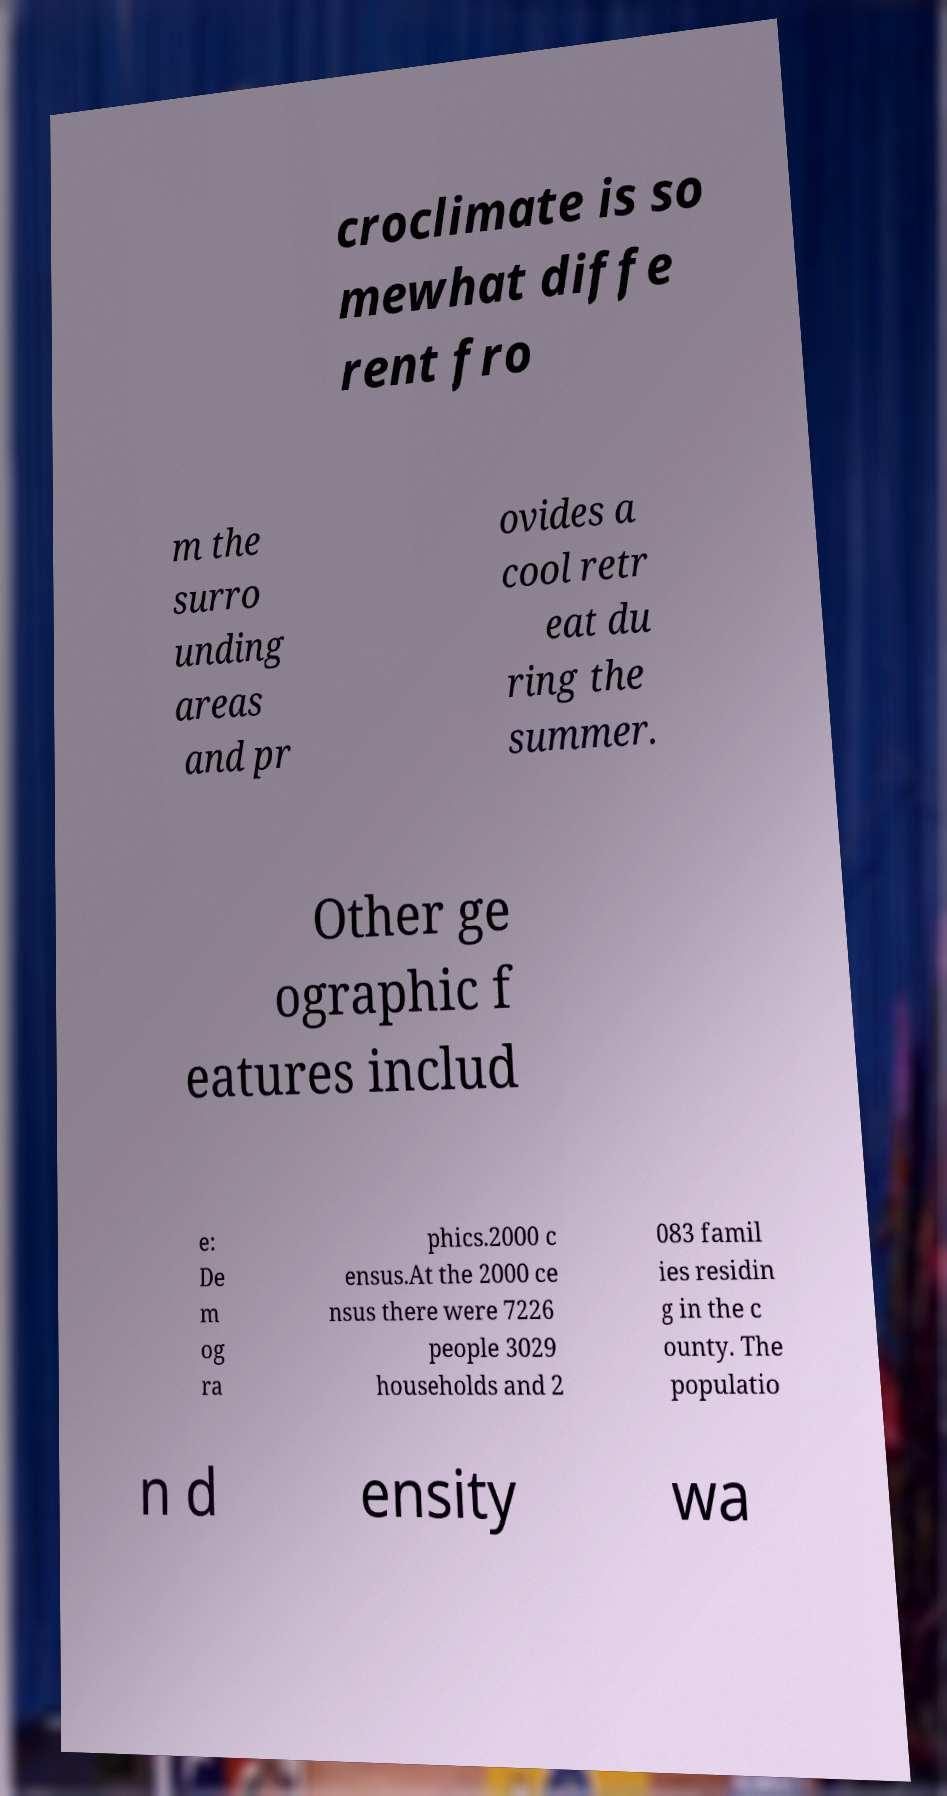Please read and relay the text visible in this image. What does it say? croclimate is so mewhat diffe rent fro m the surro unding areas and pr ovides a cool retr eat du ring the summer. Other ge ographic f eatures includ e: De m og ra phics.2000 c ensus.At the 2000 ce nsus there were 7226 people 3029 households and 2 083 famil ies residin g in the c ounty. The populatio n d ensity wa 